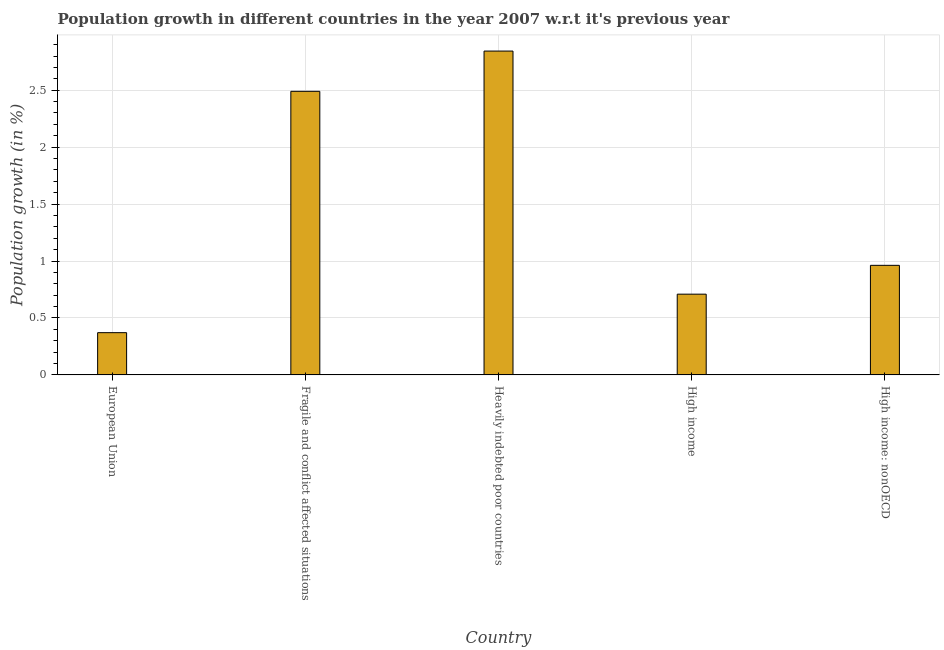Does the graph contain grids?
Offer a terse response. Yes. What is the title of the graph?
Offer a very short reply. Population growth in different countries in the year 2007 w.r.t it's previous year. What is the label or title of the Y-axis?
Give a very brief answer. Population growth (in %). What is the population growth in High income: nonOECD?
Your answer should be very brief. 0.96. Across all countries, what is the maximum population growth?
Your response must be concise. 2.84. Across all countries, what is the minimum population growth?
Your response must be concise. 0.37. In which country was the population growth maximum?
Ensure brevity in your answer.  Heavily indebted poor countries. What is the sum of the population growth?
Make the answer very short. 7.38. What is the difference between the population growth in European Union and High income?
Offer a terse response. -0.34. What is the average population growth per country?
Give a very brief answer. 1.48. What is the median population growth?
Your answer should be compact. 0.96. In how many countries, is the population growth greater than 1.8 %?
Your answer should be compact. 2. What is the ratio of the population growth in High income to that in High income: nonOECD?
Give a very brief answer. 0.74. Is the population growth in European Union less than that in Heavily indebted poor countries?
Give a very brief answer. Yes. What is the difference between the highest and the second highest population growth?
Keep it short and to the point. 0.35. What is the difference between the highest and the lowest population growth?
Offer a terse response. 2.47. In how many countries, is the population growth greater than the average population growth taken over all countries?
Provide a succinct answer. 2. How many bars are there?
Your response must be concise. 5. What is the difference between two consecutive major ticks on the Y-axis?
Provide a succinct answer. 0.5. Are the values on the major ticks of Y-axis written in scientific E-notation?
Provide a succinct answer. No. What is the Population growth (in %) in European Union?
Your answer should be very brief. 0.37. What is the Population growth (in %) in Fragile and conflict affected situations?
Offer a terse response. 2.49. What is the Population growth (in %) of Heavily indebted poor countries?
Make the answer very short. 2.84. What is the Population growth (in %) of High income?
Provide a short and direct response. 0.71. What is the Population growth (in %) of High income: nonOECD?
Make the answer very short. 0.96. What is the difference between the Population growth (in %) in European Union and Fragile and conflict affected situations?
Offer a very short reply. -2.12. What is the difference between the Population growth (in %) in European Union and Heavily indebted poor countries?
Give a very brief answer. -2.47. What is the difference between the Population growth (in %) in European Union and High income?
Give a very brief answer. -0.34. What is the difference between the Population growth (in %) in European Union and High income: nonOECD?
Provide a short and direct response. -0.59. What is the difference between the Population growth (in %) in Fragile and conflict affected situations and Heavily indebted poor countries?
Your response must be concise. -0.35. What is the difference between the Population growth (in %) in Fragile and conflict affected situations and High income?
Your answer should be very brief. 1.78. What is the difference between the Population growth (in %) in Fragile and conflict affected situations and High income: nonOECD?
Provide a succinct answer. 1.53. What is the difference between the Population growth (in %) in Heavily indebted poor countries and High income?
Offer a very short reply. 2.13. What is the difference between the Population growth (in %) in Heavily indebted poor countries and High income: nonOECD?
Give a very brief answer. 1.88. What is the difference between the Population growth (in %) in High income and High income: nonOECD?
Keep it short and to the point. -0.25. What is the ratio of the Population growth (in %) in European Union to that in Fragile and conflict affected situations?
Offer a very short reply. 0.15. What is the ratio of the Population growth (in %) in European Union to that in Heavily indebted poor countries?
Offer a terse response. 0.13. What is the ratio of the Population growth (in %) in European Union to that in High income?
Keep it short and to the point. 0.52. What is the ratio of the Population growth (in %) in European Union to that in High income: nonOECD?
Offer a terse response. 0.39. What is the ratio of the Population growth (in %) in Fragile and conflict affected situations to that in Heavily indebted poor countries?
Offer a terse response. 0.88. What is the ratio of the Population growth (in %) in Fragile and conflict affected situations to that in High income?
Offer a very short reply. 3.51. What is the ratio of the Population growth (in %) in Fragile and conflict affected situations to that in High income: nonOECD?
Offer a terse response. 2.59. What is the ratio of the Population growth (in %) in Heavily indebted poor countries to that in High income?
Offer a very short reply. 4.01. What is the ratio of the Population growth (in %) in Heavily indebted poor countries to that in High income: nonOECD?
Make the answer very short. 2.96. What is the ratio of the Population growth (in %) in High income to that in High income: nonOECD?
Make the answer very short. 0.74. 